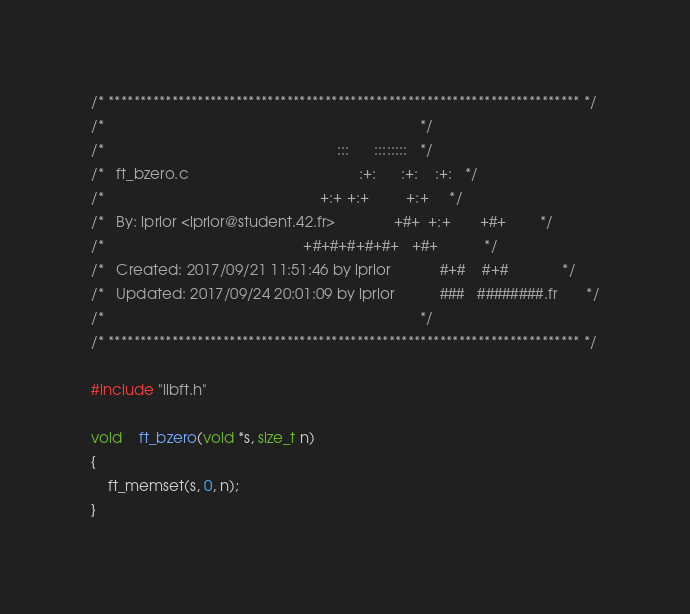<code> <loc_0><loc_0><loc_500><loc_500><_C_>/* ************************************************************************** */
/*                                                                            */
/*                                                        :::      ::::::::   */
/*   ft_bzero.c                                         :+:      :+:    :+:   */
/*                                                    +:+ +:+         +:+     */
/*   By: lprior <lprior@student.42.fr>              +#+  +:+       +#+        */
/*                                                +#+#+#+#+#+   +#+           */
/*   Created: 2017/09/21 11:51:46 by lprior            #+#    #+#             */
/*   Updated: 2017/09/24 20:01:09 by lprior           ###   ########.fr       */
/*                                                                            */
/* ************************************************************************** */

#include "libft.h"

void	ft_bzero(void *s, size_t n)
{
	ft_memset(s, 0, n);
}
</code> 